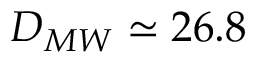<formula> <loc_0><loc_0><loc_500><loc_500>D _ { M W } \simeq 2 6 . 8</formula> 